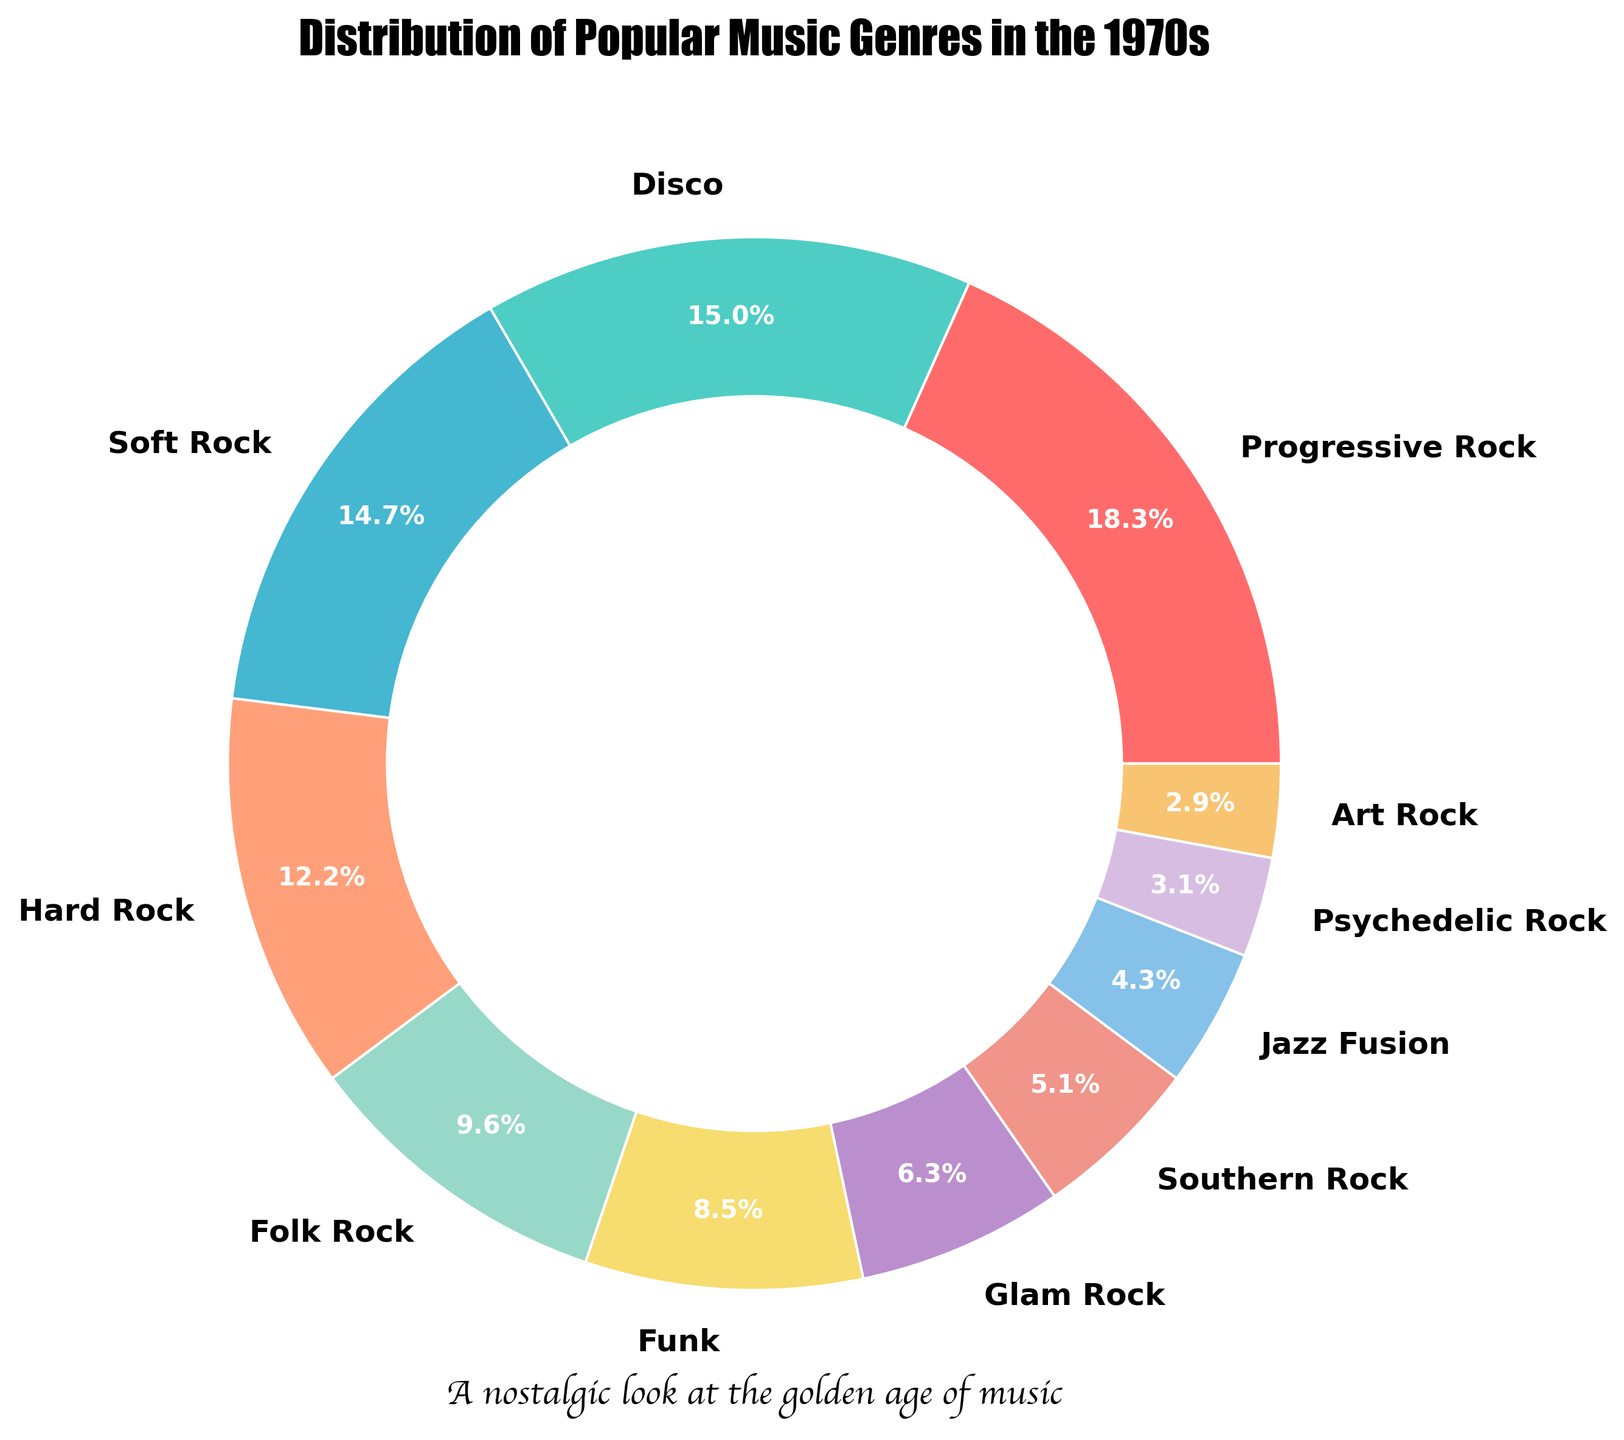What percentage of music genres in the 1970s pie chart is represented by the top three most popular subgenres combined? First, identify the top three most popular subgenres, which are Progressive Rock (18.5%), Disco (15.2%), and Soft Rock (14.8%). Then add their percentages: 18.5% + 15.2% + 14.8% = 48.5%.
Answer: 48.5% Which subgenre represents a larger share of the pie chart: Hard Rock or Folk Rock? Compare the percentages of Hard Rock (12.3%) and Folk Rock (9.7%). Since 12.3% is greater than 9.7%, Hard Rock represents a larger share.
Answer: Hard Rock By how much does the share of Progressive Rock exceed the combined shares of Psychedelic Rock and Art Rock? Calculate the combined shares of Psychedelic Rock (3.1%) and Art Rock (2.9%), which equals 6.0%. Then subtract this sum from Progressive Rock's share: 18.5% - 6.0% = 12.5%.
Answer: 12.5% Which color represents the genre Funk, and where is it located on the chart? Funk is represented by the color corresponding to its percentage (8.6%). By examining the pie chart, identify the corresponding section that is visually distinct.
Answer: Light blue (8th position in clockwise order) If you combine the genres with less than 10% share each, what total percentage do they occupy? Identify the genres with shares less than 10%: Folk Rock (9.7%), Funk (8.6%), Glam Rock (6.4%), Southern Rock (5.2%), Jazz Fusion (4.3%), Psychedelic Rock (3.1%), and Art Rock (2.9%). Add their percentages: 9.7% + 8.6% + 6.4% + 5.2% + 4.3% + 3.1% + 2.9% = 40.2%.
Answer: 40.2% Which genre has a share closest to the median value, and what is that genre? List all the genres' percentages in ascending order and find the middle value: Art Rock (2.9%), Psychedelic Rock (3.1%), Jazz Fusion (4.3%), Southern Rock (5.2%), Glam Rock (6.4%), Funk (8.6%), Folk Rock (9.7%), Hard Rock (12.3%), Soft Rock (14.8%), Disco (15.2%), Progressive Rock (18.5%). The median value is the 6th value: Funk (8.6%).
Answer: Funk, 8.6% Which two genres combined have a share closest to, but not exceeding, 20%? Identify combinations of genres and their sums close to but not over 20%. One combination is Southern Rock (5.2%) + Psychedelic Rock (3.1%) + Art Rock (2.9%) = 11.2%. Another pair is Jazz Fusion (4.3%) + Funk (8.6%) = 12.9%. After evaluating all pairs, the closest combination is Jazz Fusion and Funk, totaling 12.9%.
Answer: Jazz Fusion and Funk, 12.9% 